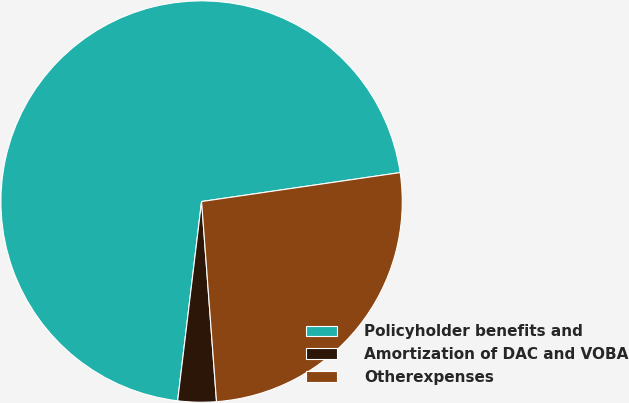Convert chart to OTSL. <chart><loc_0><loc_0><loc_500><loc_500><pie_chart><fcel>Policyholder benefits and<fcel>Amortization of DAC and VOBA<fcel>Otherexpenses<nl><fcel>70.8%<fcel>3.09%<fcel>26.12%<nl></chart> 